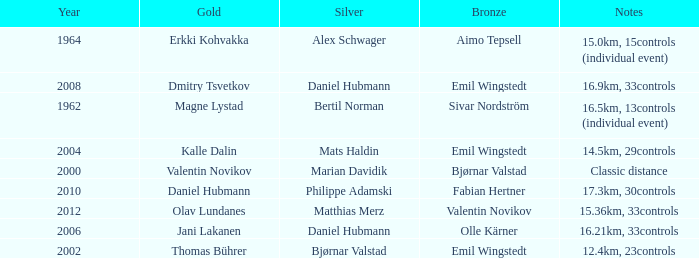WHAT YEAR HAS A SILVER FOR MATTHIAS MERZ? 2012.0. 